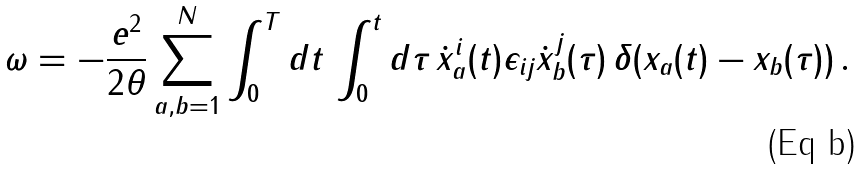Convert formula to latex. <formula><loc_0><loc_0><loc_500><loc_500>\omega = - { \frac { e ^ { 2 } } { 2 \theta } } \sum _ { a , b = 1 } ^ { N } \int _ { 0 } ^ { T } d t \, \int _ { 0 } ^ { t } d \tau \, { \dot { x } } _ { a } ^ { i } ( t ) \epsilon _ { i j } { \dot { x } } _ { b } ^ { j } ( \tau ) \, \delta ( { x } _ { a } ( t ) - { x } _ { b } ( \tau ) ) \, .</formula> 